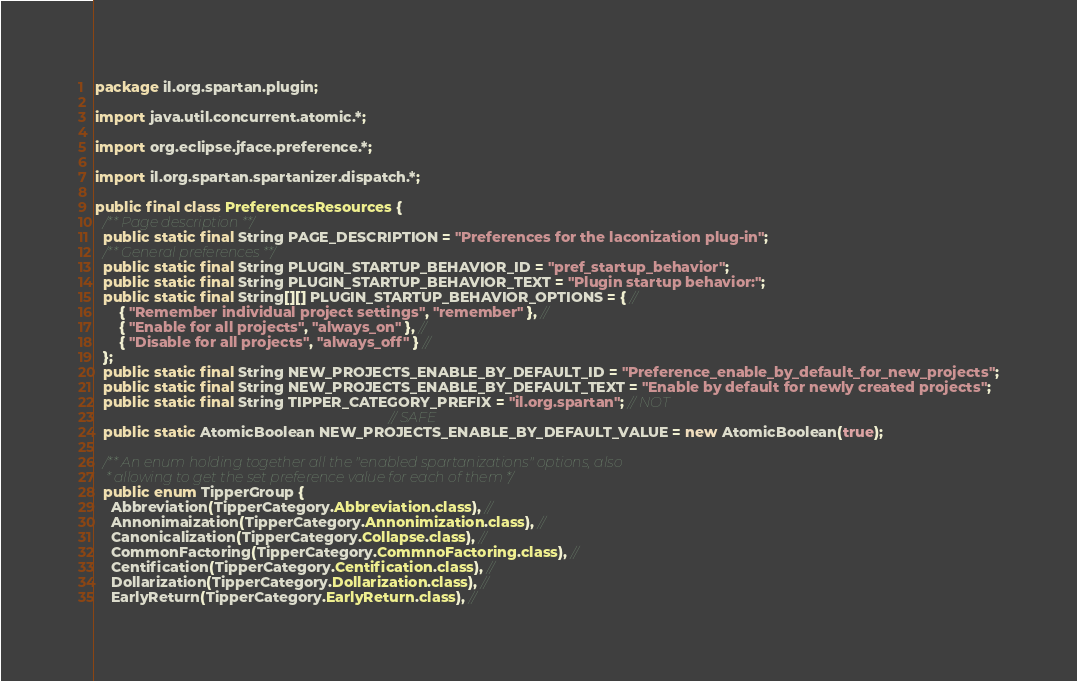<code> <loc_0><loc_0><loc_500><loc_500><_Java_>package il.org.spartan.plugin;

import java.util.concurrent.atomic.*;

import org.eclipse.jface.preference.*;

import il.org.spartan.spartanizer.dispatch.*;

public final class PreferencesResources {
  /** Page description **/
  public static final String PAGE_DESCRIPTION = "Preferences for the laconization plug-in";
  /** General preferences **/
  public static final String PLUGIN_STARTUP_BEHAVIOR_ID = "pref_startup_behavior";
  public static final String PLUGIN_STARTUP_BEHAVIOR_TEXT = "Plugin startup behavior:";
  public static final String[][] PLUGIN_STARTUP_BEHAVIOR_OPTIONS = { //
      { "Remember individual project settings", "remember" }, //
      { "Enable for all projects", "always_on" }, //
      { "Disable for all projects", "always_off" } //
  };
  public static final String NEW_PROJECTS_ENABLE_BY_DEFAULT_ID = "Preference_enable_by_default_for_new_projects";
  public static final String NEW_PROJECTS_ENABLE_BY_DEFAULT_TEXT = "Enable by default for newly created projects";
  public static final String TIPPER_CATEGORY_PREFIX = "il.org.spartan"; // NOT
                                                                        // SAFE
  public static AtomicBoolean NEW_PROJECTS_ENABLE_BY_DEFAULT_VALUE = new AtomicBoolean(true);

  /** An enum holding together all the "enabled spartanizations" options, also
   * allowing to get the set preference value for each of them */
  public enum TipperGroup {
    Abbreviation(TipperCategory.Abbreviation.class), //
    Annonimaization(TipperCategory.Annonimization.class), //
    Canonicalization(TipperCategory.Collapse.class), //
    CommonFactoring(TipperCategory.CommnoFactoring.class), //
    Centification(TipperCategory.Centification.class), //
    Dollarization(TipperCategory.Dollarization.class), //
    EarlyReturn(TipperCategory.EarlyReturn.class), //</code> 